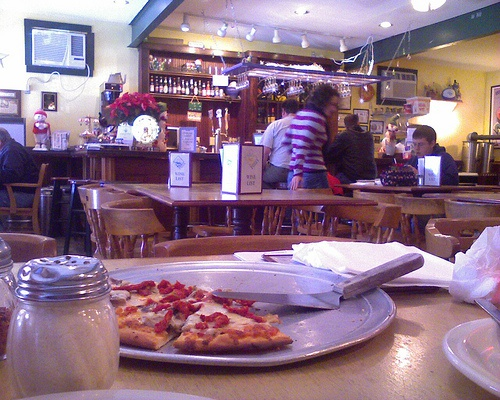Describe the objects in this image and their specific colors. I can see dining table in white, gray, lightpink, brown, and black tones, pizza in white, brown, lightpink, and maroon tones, dining table in white, violet, purple, gray, and maroon tones, people in white, purple, navy, black, and violet tones, and knife in white, purple, and violet tones in this image. 